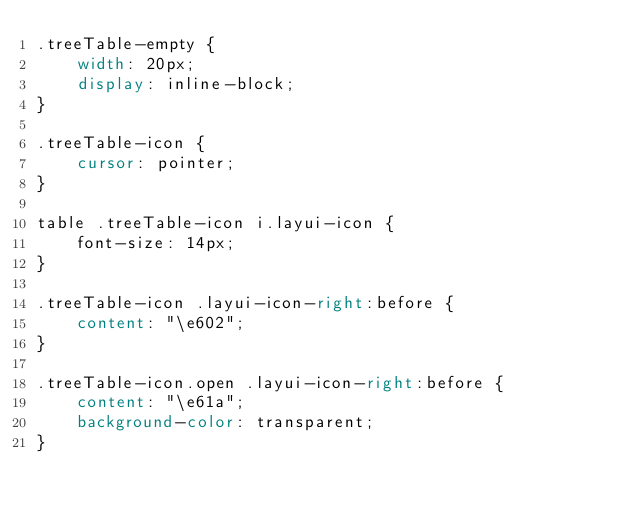Convert code to text. <code><loc_0><loc_0><loc_500><loc_500><_CSS_>.treeTable-empty {
    width: 20px;
    display: inline-block;
}

.treeTable-icon {
    cursor: pointer;
}

table .treeTable-icon i.layui-icon {
    font-size: 14px;
}

.treeTable-icon .layui-icon-right:before {
    content: "\e602";
}

.treeTable-icon.open .layui-icon-right:before {
    content: "\e61a";
    background-color: transparent;
}

</code> 